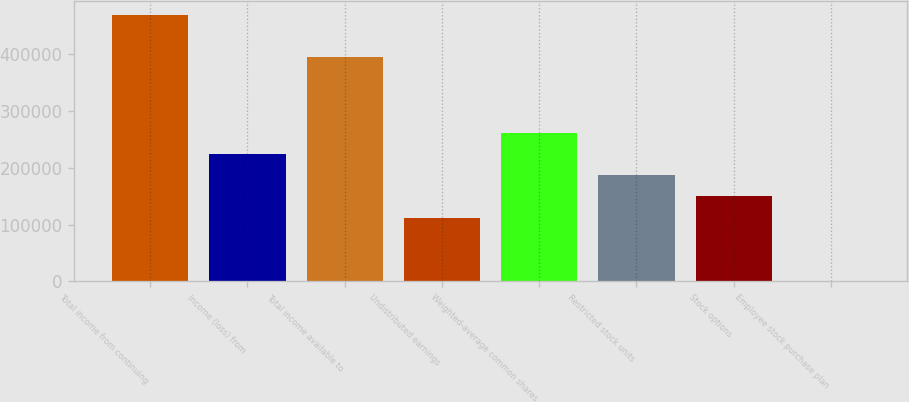Convert chart. <chart><loc_0><loc_0><loc_500><loc_500><bar_chart><fcel>Total income from continuing<fcel>Income (loss) from<fcel>Total income available to<fcel>Undistributed earnings<fcel>Weighted-average common shares<fcel>Restricted stock units<fcel>Stock options<fcel>Employee stock purchase plan<nl><fcel>470175<fcel>224499<fcel>395342<fcel>112250<fcel>261915<fcel>187082<fcel>149666<fcel>1<nl></chart> 